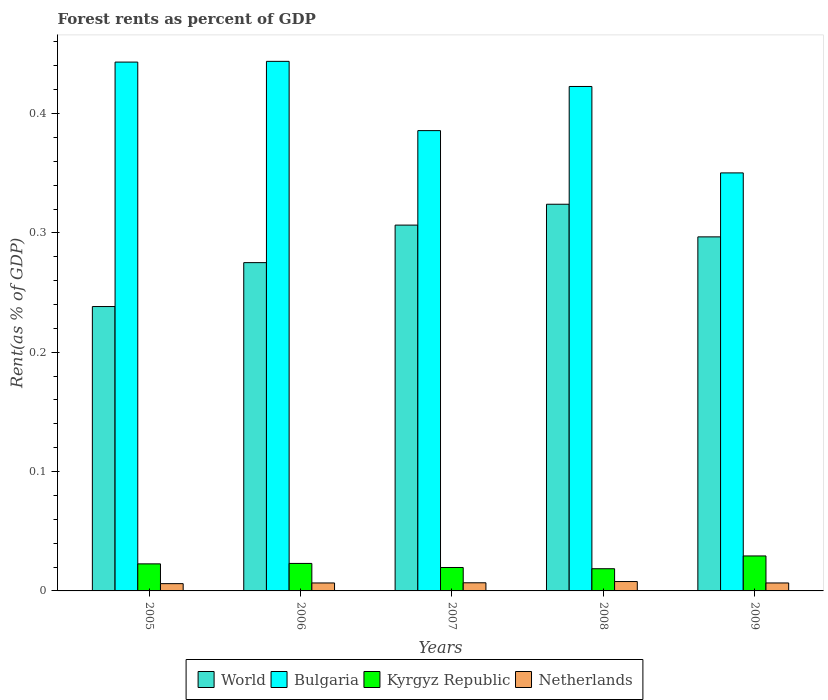How many different coloured bars are there?
Ensure brevity in your answer.  4. Are the number of bars on each tick of the X-axis equal?
Ensure brevity in your answer.  Yes. In how many cases, is the number of bars for a given year not equal to the number of legend labels?
Offer a terse response. 0. What is the forest rent in World in 2005?
Offer a terse response. 0.24. Across all years, what is the maximum forest rent in Kyrgyz Republic?
Keep it short and to the point. 0.03. Across all years, what is the minimum forest rent in Kyrgyz Republic?
Give a very brief answer. 0.02. In which year was the forest rent in Bulgaria maximum?
Keep it short and to the point. 2006. What is the total forest rent in Netherlands in the graph?
Your answer should be very brief. 0.03. What is the difference between the forest rent in Bulgaria in 2007 and that in 2008?
Keep it short and to the point. -0.04. What is the difference between the forest rent in Kyrgyz Republic in 2007 and the forest rent in Netherlands in 2008?
Keep it short and to the point. 0.01. What is the average forest rent in Bulgaria per year?
Offer a terse response. 0.41. In the year 2006, what is the difference between the forest rent in Kyrgyz Republic and forest rent in Netherlands?
Your answer should be very brief. 0.02. What is the ratio of the forest rent in Netherlands in 2006 to that in 2007?
Offer a very short reply. 0.98. Is the difference between the forest rent in Kyrgyz Republic in 2006 and 2008 greater than the difference between the forest rent in Netherlands in 2006 and 2008?
Your answer should be very brief. Yes. What is the difference between the highest and the second highest forest rent in Bulgaria?
Your answer should be very brief. 0. What is the difference between the highest and the lowest forest rent in Bulgaria?
Provide a succinct answer. 0.09. In how many years, is the forest rent in Kyrgyz Republic greater than the average forest rent in Kyrgyz Republic taken over all years?
Provide a short and direct response. 3. Is the sum of the forest rent in Netherlands in 2007 and 2008 greater than the maximum forest rent in Bulgaria across all years?
Your answer should be very brief. No. What does the 1st bar from the left in 2009 represents?
Offer a very short reply. World. What does the 2nd bar from the right in 2009 represents?
Your answer should be compact. Kyrgyz Republic. How many bars are there?
Provide a succinct answer. 20. Are all the bars in the graph horizontal?
Your answer should be very brief. No. How many years are there in the graph?
Make the answer very short. 5. What is the difference between two consecutive major ticks on the Y-axis?
Your answer should be compact. 0.1. Are the values on the major ticks of Y-axis written in scientific E-notation?
Your answer should be compact. No. Does the graph contain any zero values?
Your answer should be very brief. No. Where does the legend appear in the graph?
Provide a short and direct response. Bottom center. How many legend labels are there?
Your answer should be very brief. 4. How are the legend labels stacked?
Keep it short and to the point. Horizontal. What is the title of the graph?
Your answer should be very brief. Forest rents as percent of GDP. Does "Haiti" appear as one of the legend labels in the graph?
Provide a succinct answer. No. What is the label or title of the X-axis?
Offer a very short reply. Years. What is the label or title of the Y-axis?
Provide a short and direct response. Rent(as % of GDP). What is the Rent(as % of GDP) in World in 2005?
Make the answer very short. 0.24. What is the Rent(as % of GDP) in Bulgaria in 2005?
Your response must be concise. 0.44. What is the Rent(as % of GDP) of Kyrgyz Republic in 2005?
Your answer should be compact. 0.02. What is the Rent(as % of GDP) of Netherlands in 2005?
Ensure brevity in your answer.  0.01. What is the Rent(as % of GDP) of World in 2006?
Your answer should be very brief. 0.28. What is the Rent(as % of GDP) in Bulgaria in 2006?
Make the answer very short. 0.44. What is the Rent(as % of GDP) of Kyrgyz Republic in 2006?
Your answer should be very brief. 0.02. What is the Rent(as % of GDP) in Netherlands in 2006?
Provide a short and direct response. 0.01. What is the Rent(as % of GDP) of World in 2007?
Provide a short and direct response. 0.31. What is the Rent(as % of GDP) in Bulgaria in 2007?
Give a very brief answer. 0.39. What is the Rent(as % of GDP) in Kyrgyz Republic in 2007?
Your answer should be very brief. 0.02. What is the Rent(as % of GDP) in Netherlands in 2007?
Offer a terse response. 0.01. What is the Rent(as % of GDP) of World in 2008?
Provide a short and direct response. 0.32. What is the Rent(as % of GDP) in Bulgaria in 2008?
Your response must be concise. 0.42. What is the Rent(as % of GDP) in Kyrgyz Republic in 2008?
Offer a very short reply. 0.02. What is the Rent(as % of GDP) of Netherlands in 2008?
Keep it short and to the point. 0.01. What is the Rent(as % of GDP) in World in 2009?
Provide a short and direct response. 0.3. What is the Rent(as % of GDP) in Bulgaria in 2009?
Provide a succinct answer. 0.35. What is the Rent(as % of GDP) of Kyrgyz Republic in 2009?
Give a very brief answer. 0.03. What is the Rent(as % of GDP) in Netherlands in 2009?
Offer a very short reply. 0.01. Across all years, what is the maximum Rent(as % of GDP) in World?
Provide a short and direct response. 0.32. Across all years, what is the maximum Rent(as % of GDP) in Bulgaria?
Your response must be concise. 0.44. Across all years, what is the maximum Rent(as % of GDP) of Kyrgyz Republic?
Provide a succinct answer. 0.03. Across all years, what is the maximum Rent(as % of GDP) in Netherlands?
Make the answer very short. 0.01. Across all years, what is the minimum Rent(as % of GDP) in World?
Your answer should be compact. 0.24. Across all years, what is the minimum Rent(as % of GDP) in Bulgaria?
Your response must be concise. 0.35. Across all years, what is the minimum Rent(as % of GDP) in Kyrgyz Republic?
Make the answer very short. 0.02. Across all years, what is the minimum Rent(as % of GDP) of Netherlands?
Your answer should be very brief. 0.01. What is the total Rent(as % of GDP) in World in the graph?
Provide a short and direct response. 1.44. What is the total Rent(as % of GDP) of Bulgaria in the graph?
Offer a terse response. 2.05. What is the total Rent(as % of GDP) in Kyrgyz Republic in the graph?
Keep it short and to the point. 0.11. What is the total Rent(as % of GDP) of Netherlands in the graph?
Your response must be concise. 0.03. What is the difference between the Rent(as % of GDP) in World in 2005 and that in 2006?
Provide a succinct answer. -0.04. What is the difference between the Rent(as % of GDP) of Bulgaria in 2005 and that in 2006?
Ensure brevity in your answer.  -0. What is the difference between the Rent(as % of GDP) of Kyrgyz Republic in 2005 and that in 2006?
Ensure brevity in your answer.  -0. What is the difference between the Rent(as % of GDP) of Netherlands in 2005 and that in 2006?
Keep it short and to the point. -0. What is the difference between the Rent(as % of GDP) in World in 2005 and that in 2007?
Your answer should be compact. -0.07. What is the difference between the Rent(as % of GDP) of Bulgaria in 2005 and that in 2007?
Offer a terse response. 0.06. What is the difference between the Rent(as % of GDP) in Kyrgyz Republic in 2005 and that in 2007?
Make the answer very short. 0. What is the difference between the Rent(as % of GDP) of Netherlands in 2005 and that in 2007?
Your response must be concise. -0. What is the difference between the Rent(as % of GDP) of World in 2005 and that in 2008?
Offer a terse response. -0.09. What is the difference between the Rent(as % of GDP) of Bulgaria in 2005 and that in 2008?
Make the answer very short. 0.02. What is the difference between the Rent(as % of GDP) of Kyrgyz Republic in 2005 and that in 2008?
Ensure brevity in your answer.  0. What is the difference between the Rent(as % of GDP) in Netherlands in 2005 and that in 2008?
Your response must be concise. -0. What is the difference between the Rent(as % of GDP) in World in 2005 and that in 2009?
Provide a succinct answer. -0.06. What is the difference between the Rent(as % of GDP) of Bulgaria in 2005 and that in 2009?
Provide a short and direct response. 0.09. What is the difference between the Rent(as % of GDP) of Kyrgyz Republic in 2005 and that in 2009?
Provide a short and direct response. -0.01. What is the difference between the Rent(as % of GDP) of Netherlands in 2005 and that in 2009?
Make the answer very short. -0. What is the difference between the Rent(as % of GDP) of World in 2006 and that in 2007?
Your answer should be very brief. -0.03. What is the difference between the Rent(as % of GDP) of Bulgaria in 2006 and that in 2007?
Offer a terse response. 0.06. What is the difference between the Rent(as % of GDP) of Kyrgyz Republic in 2006 and that in 2007?
Provide a succinct answer. 0. What is the difference between the Rent(as % of GDP) of Netherlands in 2006 and that in 2007?
Your response must be concise. -0. What is the difference between the Rent(as % of GDP) in World in 2006 and that in 2008?
Your answer should be compact. -0.05. What is the difference between the Rent(as % of GDP) in Bulgaria in 2006 and that in 2008?
Your answer should be very brief. 0.02. What is the difference between the Rent(as % of GDP) in Kyrgyz Republic in 2006 and that in 2008?
Keep it short and to the point. 0. What is the difference between the Rent(as % of GDP) in Netherlands in 2006 and that in 2008?
Ensure brevity in your answer.  -0. What is the difference between the Rent(as % of GDP) in World in 2006 and that in 2009?
Provide a succinct answer. -0.02. What is the difference between the Rent(as % of GDP) in Bulgaria in 2006 and that in 2009?
Give a very brief answer. 0.09. What is the difference between the Rent(as % of GDP) of Kyrgyz Republic in 2006 and that in 2009?
Offer a very short reply. -0.01. What is the difference between the Rent(as % of GDP) of World in 2007 and that in 2008?
Make the answer very short. -0.02. What is the difference between the Rent(as % of GDP) of Bulgaria in 2007 and that in 2008?
Provide a short and direct response. -0.04. What is the difference between the Rent(as % of GDP) of Kyrgyz Republic in 2007 and that in 2008?
Your answer should be compact. 0. What is the difference between the Rent(as % of GDP) in Netherlands in 2007 and that in 2008?
Give a very brief answer. -0. What is the difference between the Rent(as % of GDP) of World in 2007 and that in 2009?
Give a very brief answer. 0.01. What is the difference between the Rent(as % of GDP) of Bulgaria in 2007 and that in 2009?
Offer a very short reply. 0.04. What is the difference between the Rent(as % of GDP) of Kyrgyz Republic in 2007 and that in 2009?
Ensure brevity in your answer.  -0.01. What is the difference between the Rent(as % of GDP) in World in 2008 and that in 2009?
Keep it short and to the point. 0.03. What is the difference between the Rent(as % of GDP) of Bulgaria in 2008 and that in 2009?
Provide a short and direct response. 0.07. What is the difference between the Rent(as % of GDP) of Kyrgyz Republic in 2008 and that in 2009?
Your answer should be very brief. -0.01. What is the difference between the Rent(as % of GDP) in Netherlands in 2008 and that in 2009?
Keep it short and to the point. 0. What is the difference between the Rent(as % of GDP) of World in 2005 and the Rent(as % of GDP) of Bulgaria in 2006?
Ensure brevity in your answer.  -0.21. What is the difference between the Rent(as % of GDP) in World in 2005 and the Rent(as % of GDP) in Kyrgyz Republic in 2006?
Your answer should be compact. 0.22. What is the difference between the Rent(as % of GDP) of World in 2005 and the Rent(as % of GDP) of Netherlands in 2006?
Give a very brief answer. 0.23. What is the difference between the Rent(as % of GDP) of Bulgaria in 2005 and the Rent(as % of GDP) of Kyrgyz Republic in 2006?
Provide a succinct answer. 0.42. What is the difference between the Rent(as % of GDP) in Bulgaria in 2005 and the Rent(as % of GDP) in Netherlands in 2006?
Make the answer very short. 0.44. What is the difference between the Rent(as % of GDP) in Kyrgyz Republic in 2005 and the Rent(as % of GDP) in Netherlands in 2006?
Your answer should be compact. 0.02. What is the difference between the Rent(as % of GDP) of World in 2005 and the Rent(as % of GDP) of Bulgaria in 2007?
Ensure brevity in your answer.  -0.15. What is the difference between the Rent(as % of GDP) of World in 2005 and the Rent(as % of GDP) of Kyrgyz Republic in 2007?
Your response must be concise. 0.22. What is the difference between the Rent(as % of GDP) in World in 2005 and the Rent(as % of GDP) in Netherlands in 2007?
Your answer should be very brief. 0.23. What is the difference between the Rent(as % of GDP) in Bulgaria in 2005 and the Rent(as % of GDP) in Kyrgyz Republic in 2007?
Offer a very short reply. 0.42. What is the difference between the Rent(as % of GDP) of Bulgaria in 2005 and the Rent(as % of GDP) of Netherlands in 2007?
Make the answer very short. 0.44. What is the difference between the Rent(as % of GDP) of Kyrgyz Republic in 2005 and the Rent(as % of GDP) of Netherlands in 2007?
Your answer should be compact. 0.02. What is the difference between the Rent(as % of GDP) of World in 2005 and the Rent(as % of GDP) of Bulgaria in 2008?
Provide a succinct answer. -0.18. What is the difference between the Rent(as % of GDP) in World in 2005 and the Rent(as % of GDP) in Kyrgyz Republic in 2008?
Your response must be concise. 0.22. What is the difference between the Rent(as % of GDP) in World in 2005 and the Rent(as % of GDP) in Netherlands in 2008?
Offer a very short reply. 0.23. What is the difference between the Rent(as % of GDP) in Bulgaria in 2005 and the Rent(as % of GDP) in Kyrgyz Republic in 2008?
Provide a succinct answer. 0.42. What is the difference between the Rent(as % of GDP) in Bulgaria in 2005 and the Rent(as % of GDP) in Netherlands in 2008?
Offer a very short reply. 0.44. What is the difference between the Rent(as % of GDP) in Kyrgyz Republic in 2005 and the Rent(as % of GDP) in Netherlands in 2008?
Your answer should be compact. 0.01. What is the difference between the Rent(as % of GDP) of World in 2005 and the Rent(as % of GDP) of Bulgaria in 2009?
Your answer should be compact. -0.11. What is the difference between the Rent(as % of GDP) in World in 2005 and the Rent(as % of GDP) in Kyrgyz Republic in 2009?
Your response must be concise. 0.21. What is the difference between the Rent(as % of GDP) of World in 2005 and the Rent(as % of GDP) of Netherlands in 2009?
Ensure brevity in your answer.  0.23. What is the difference between the Rent(as % of GDP) of Bulgaria in 2005 and the Rent(as % of GDP) of Kyrgyz Republic in 2009?
Ensure brevity in your answer.  0.41. What is the difference between the Rent(as % of GDP) in Bulgaria in 2005 and the Rent(as % of GDP) in Netherlands in 2009?
Ensure brevity in your answer.  0.44. What is the difference between the Rent(as % of GDP) in Kyrgyz Republic in 2005 and the Rent(as % of GDP) in Netherlands in 2009?
Ensure brevity in your answer.  0.02. What is the difference between the Rent(as % of GDP) of World in 2006 and the Rent(as % of GDP) of Bulgaria in 2007?
Give a very brief answer. -0.11. What is the difference between the Rent(as % of GDP) in World in 2006 and the Rent(as % of GDP) in Kyrgyz Republic in 2007?
Your answer should be compact. 0.26. What is the difference between the Rent(as % of GDP) of World in 2006 and the Rent(as % of GDP) of Netherlands in 2007?
Provide a succinct answer. 0.27. What is the difference between the Rent(as % of GDP) of Bulgaria in 2006 and the Rent(as % of GDP) of Kyrgyz Republic in 2007?
Offer a terse response. 0.42. What is the difference between the Rent(as % of GDP) of Bulgaria in 2006 and the Rent(as % of GDP) of Netherlands in 2007?
Your answer should be very brief. 0.44. What is the difference between the Rent(as % of GDP) in Kyrgyz Republic in 2006 and the Rent(as % of GDP) in Netherlands in 2007?
Provide a succinct answer. 0.02. What is the difference between the Rent(as % of GDP) of World in 2006 and the Rent(as % of GDP) of Bulgaria in 2008?
Give a very brief answer. -0.15. What is the difference between the Rent(as % of GDP) of World in 2006 and the Rent(as % of GDP) of Kyrgyz Republic in 2008?
Offer a very short reply. 0.26. What is the difference between the Rent(as % of GDP) of World in 2006 and the Rent(as % of GDP) of Netherlands in 2008?
Offer a very short reply. 0.27. What is the difference between the Rent(as % of GDP) in Bulgaria in 2006 and the Rent(as % of GDP) in Kyrgyz Republic in 2008?
Provide a short and direct response. 0.43. What is the difference between the Rent(as % of GDP) in Bulgaria in 2006 and the Rent(as % of GDP) in Netherlands in 2008?
Offer a terse response. 0.44. What is the difference between the Rent(as % of GDP) of Kyrgyz Republic in 2006 and the Rent(as % of GDP) of Netherlands in 2008?
Offer a terse response. 0.02. What is the difference between the Rent(as % of GDP) of World in 2006 and the Rent(as % of GDP) of Bulgaria in 2009?
Offer a very short reply. -0.08. What is the difference between the Rent(as % of GDP) in World in 2006 and the Rent(as % of GDP) in Kyrgyz Republic in 2009?
Offer a terse response. 0.25. What is the difference between the Rent(as % of GDP) of World in 2006 and the Rent(as % of GDP) of Netherlands in 2009?
Your answer should be compact. 0.27. What is the difference between the Rent(as % of GDP) in Bulgaria in 2006 and the Rent(as % of GDP) in Kyrgyz Republic in 2009?
Make the answer very short. 0.41. What is the difference between the Rent(as % of GDP) in Bulgaria in 2006 and the Rent(as % of GDP) in Netherlands in 2009?
Give a very brief answer. 0.44. What is the difference between the Rent(as % of GDP) in Kyrgyz Republic in 2006 and the Rent(as % of GDP) in Netherlands in 2009?
Your answer should be very brief. 0.02. What is the difference between the Rent(as % of GDP) of World in 2007 and the Rent(as % of GDP) of Bulgaria in 2008?
Provide a succinct answer. -0.12. What is the difference between the Rent(as % of GDP) of World in 2007 and the Rent(as % of GDP) of Kyrgyz Republic in 2008?
Make the answer very short. 0.29. What is the difference between the Rent(as % of GDP) of World in 2007 and the Rent(as % of GDP) of Netherlands in 2008?
Offer a very short reply. 0.3. What is the difference between the Rent(as % of GDP) of Bulgaria in 2007 and the Rent(as % of GDP) of Kyrgyz Republic in 2008?
Provide a short and direct response. 0.37. What is the difference between the Rent(as % of GDP) in Bulgaria in 2007 and the Rent(as % of GDP) in Netherlands in 2008?
Your response must be concise. 0.38. What is the difference between the Rent(as % of GDP) in Kyrgyz Republic in 2007 and the Rent(as % of GDP) in Netherlands in 2008?
Make the answer very short. 0.01. What is the difference between the Rent(as % of GDP) of World in 2007 and the Rent(as % of GDP) of Bulgaria in 2009?
Your answer should be compact. -0.04. What is the difference between the Rent(as % of GDP) of World in 2007 and the Rent(as % of GDP) of Kyrgyz Republic in 2009?
Provide a short and direct response. 0.28. What is the difference between the Rent(as % of GDP) in World in 2007 and the Rent(as % of GDP) in Netherlands in 2009?
Your answer should be very brief. 0.3. What is the difference between the Rent(as % of GDP) of Bulgaria in 2007 and the Rent(as % of GDP) of Kyrgyz Republic in 2009?
Your answer should be very brief. 0.36. What is the difference between the Rent(as % of GDP) of Bulgaria in 2007 and the Rent(as % of GDP) of Netherlands in 2009?
Make the answer very short. 0.38. What is the difference between the Rent(as % of GDP) of Kyrgyz Republic in 2007 and the Rent(as % of GDP) of Netherlands in 2009?
Provide a succinct answer. 0.01. What is the difference between the Rent(as % of GDP) in World in 2008 and the Rent(as % of GDP) in Bulgaria in 2009?
Your answer should be compact. -0.03. What is the difference between the Rent(as % of GDP) of World in 2008 and the Rent(as % of GDP) of Kyrgyz Republic in 2009?
Provide a short and direct response. 0.29. What is the difference between the Rent(as % of GDP) of World in 2008 and the Rent(as % of GDP) of Netherlands in 2009?
Your answer should be very brief. 0.32. What is the difference between the Rent(as % of GDP) in Bulgaria in 2008 and the Rent(as % of GDP) in Kyrgyz Republic in 2009?
Your answer should be very brief. 0.39. What is the difference between the Rent(as % of GDP) of Bulgaria in 2008 and the Rent(as % of GDP) of Netherlands in 2009?
Provide a short and direct response. 0.42. What is the difference between the Rent(as % of GDP) in Kyrgyz Republic in 2008 and the Rent(as % of GDP) in Netherlands in 2009?
Your response must be concise. 0.01. What is the average Rent(as % of GDP) in World per year?
Your answer should be compact. 0.29. What is the average Rent(as % of GDP) in Bulgaria per year?
Your response must be concise. 0.41. What is the average Rent(as % of GDP) in Kyrgyz Republic per year?
Make the answer very short. 0.02. What is the average Rent(as % of GDP) of Netherlands per year?
Provide a succinct answer. 0.01. In the year 2005, what is the difference between the Rent(as % of GDP) of World and Rent(as % of GDP) of Bulgaria?
Provide a succinct answer. -0.2. In the year 2005, what is the difference between the Rent(as % of GDP) in World and Rent(as % of GDP) in Kyrgyz Republic?
Offer a very short reply. 0.22. In the year 2005, what is the difference between the Rent(as % of GDP) of World and Rent(as % of GDP) of Netherlands?
Your answer should be compact. 0.23. In the year 2005, what is the difference between the Rent(as % of GDP) in Bulgaria and Rent(as % of GDP) in Kyrgyz Republic?
Your answer should be compact. 0.42. In the year 2005, what is the difference between the Rent(as % of GDP) of Bulgaria and Rent(as % of GDP) of Netherlands?
Give a very brief answer. 0.44. In the year 2005, what is the difference between the Rent(as % of GDP) in Kyrgyz Republic and Rent(as % of GDP) in Netherlands?
Make the answer very short. 0.02. In the year 2006, what is the difference between the Rent(as % of GDP) of World and Rent(as % of GDP) of Bulgaria?
Keep it short and to the point. -0.17. In the year 2006, what is the difference between the Rent(as % of GDP) of World and Rent(as % of GDP) of Kyrgyz Republic?
Provide a succinct answer. 0.25. In the year 2006, what is the difference between the Rent(as % of GDP) of World and Rent(as % of GDP) of Netherlands?
Provide a short and direct response. 0.27. In the year 2006, what is the difference between the Rent(as % of GDP) in Bulgaria and Rent(as % of GDP) in Kyrgyz Republic?
Make the answer very short. 0.42. In the year 2006, what is the difference between the Rent(as % of GDP) of Bulgaria and Rent(as % of GDP) of Netherlands?
Your answer should be compact. 0.44. In the year 2006, what is the difference between the Rent(as % of GDP) of Kyrgyz Republic and Rent(as % of GDP) of Netherlands?
Ensure brevity in your answer.  0.02. In the year 2007, what is the difference between the Rent(as % of GDP) of World and Rent(as % of GDP) of Bulgaria?
Provide a succinct answer. -0.08. In the year 2007, what is the difference between the Rent(as % of GDP) in World and Rent(as % of GDP) in Kyrgyz Republic?
Make the answer very short. 0.29. In the year 2007, what is the difference between the Rent(as % of GDP) in World and Rent(as % of GDP) in Netherlands?
Provide a short and direct response. 0.3. In the year 2007, what is the difference between the Rent(as % of GDP) in Bulgaria and Rent(as % of GDP) in Kyrgyz Republic?
Offer a very short reply. 0.37. In the year 2007, what is the difference between the Rent(as % of GDP) of Bulgaria and Rent(as % of GDP) of Netherlands?
Provide a short and direct response. 0.38. In the year 2007, what is the difference between the Rent(as % of GDP) in Kyrgyz Republic and Rent(as % of GDP) in Netherlands?
Offer a terse response. 0.01. In the year 2008, what is the difference between the Rent(as % of GDP) in World and Rent(as % of GDP) in Bulgaria?
Offer a terse response. -0.1. In the year 2008, what is the difference between the Rent(as % of GDP) in World and Rent(as % of GDP) in Kyrgyz Republic?
Provide a succinct answer. 0.31. In the year 2008, what is the difference between the Rent(as % of GDP) of World and Rent(as % of GDP) of Netherlands?
Ensure brevity in your answer.  0.32. In the year 2008, what is the difference between the Rent(as % of GDP) in Bulgaria and Rent(as % of GDP) in Kyrgyz Republic?
Give a very brief answer. 0.4. In the year 2008, what is the difference between the Rent(as % of GDP) in Bulgaria and Rent(as % of GDP) in Netherlands?
Your response must be concise. 0.41. In the year 2008, what is the difference between the Rent(as % of GDP) in Kyrgyz Republic and Rent(as % of GDP) in Netherlands?
Ensure brevity in your answer.  0.01. In the year 2009, what is the difference between the Rent(as % of GDP) of World and Rent(as % of GDP) of Bulgaria?
Offer a terse response. -0.05. In the year 2009, what is the difference between the Rent(as % of GDP) of World and Rent(as % of GDP) of Kyrgyz Republic?
Your answer should be very brief. 0.27. In the year 2009, what is the difference between the Rent(as % of GDP) of World and Rent(as % of GDP) of Netherlands?
Offer a very short reply. 0.29. In the year 2009, what is the difference between the Rent(as % of GDP) of Bulgaria and Rent(as % of GDP) of Kyrgyz Republic?
Ensure brevity in your answer.  0.32. In the year 2009, what is the difference between the Rent(as % of GDP) in Bulgaria and Rent(as % of GDP) in Netherlands?
Your response must be concise. 0.34. In the year 2009, what is the difference between the Rent(as % of GDP) in Kyrgyz Republic and Rent(as % of GDP) in Netherlands?
Offer a terse response. 0.02. What is the ratio of the Rent(as % of GDP) in World in 2005 to that in 2006?
Provide a succinct answer. 0.87. What is the ratio of the Rent(as % of GDP) of Kyrgyz Republic in 2005 to that in 2006?
Give a very brief answer. 0.98. What is the ratio of the Rent(as % of GDP) of Netherlands in 2005 to that in 2006?
Ensure brevity in your answer.  0.91. What is the ratio of the Rent(as % of GDP) of World in 2005 to that in 2007?
Offer a terse response. 0.78. What is the ratio of the Rent(as % of GDP) in Bulgaria in 2005 to that in 2007?
Offer a very short reply. 1.15. What is the ratio of the Rent(as % of GDP) in Kyrgyz Republic in 2005 to that in 2007?
Offer a very short reply. 1.15. What is the ratio of the Rent(as % of GDP) in Netherlands in 2005 to that in 2007?
Provide a short and direct response. 0.89. What is the ratio of the Rent(as % of GDP) in World in 2005 to that in 2008?
Provide a succinct answer. 0.74. What is the ratio of the Rent(as % of GDP) of Bulgaria in 2005 to that in 2008?
Offer a terse response. 1.05. What is the ratio of the Rent(as % of GDP) in Kyrgyz Republic in 2005 to that in 2008?
Keep it short and to the point. 1.22. What is the ratio of the Rent(as % of GDP) in Netherlands in 2005 to that in 2008?
Offer a very short reply. 0.77. What is the ratio of the Rent(as % of GDP) of World in 2005 to that in 2009?
Provide a succinct answer. 0.8. What is the ratio of the Rent(as % of GDP) in Bulgaria in 2005 to that in 2009?
Make the answer very short. 1.27. What is the ratio of the Rent(as % of GDP) of Kyrgyz Republic in 2005 to that in 2009?
Provide a short and direct response. 0.77. What is the ratio of the Rent(as % of GDP) of Netherlands in 2005 to that in 2009?
Your response must be concise. 0.91. What is the ratio of the Rent(as % of GDP) of World in 2006 to that in 2007?
Keep it short and to the point. 0.9. What is the ratio of the Rent(as % of GDP) in Bulgaria in 2006 to that in 2007?
Provide a succinct answer. 1.15. What is the ratio of the Rent(as % of GDP) in Kyrgyz Republic in 2006 to that in 2007?
Your response must be concise. 1.17. What is the ratio of the Rent(as % of GDP) in Netherlands in 2006 to that in 2007?
Provide a succinct answer. 0.98. What is the ratio of the Rent(as % of GDP) of World in 2006 to that in 2008?
Ensure brevity in your answer.  0.85. What is the ratio of the Rent(as % of GDP) in Bulgaria in 2006 to that in 2008?
Offer a terse response. 1.05. What is the ratio of the Rent(as % of GDP) in Kyrgyz Republic in 2006 to that in 2008?
Offer a terse response. 1.24. What is the ratio of the Rent(as % of GDP) of Netherlands in 2006 to that in 2008?
Your answer should be compact. 0.85. What is the ratio of the Rent(as % of GDP) of World in 2006 to that in 2009?
Your answer should be very brief. 0.93. What is the ratio of the Rent(as % of GDP) in Bulgaria in 2006 to that in 2009?
Offer a terse response. 1.27. What is the ratio of the Rent(as % of GDP) in Kyrgyz Republic in 2006 to that in 2009?
Offer a very short reply. 0.79. What is the ratio of the Rent(as % of GDP) in World in 2007 to that in 2008?
Offer a very short reply. 0.95. What is the ratio of the Rent(as % of GDP) in Bulgaria in 2007 to that in 2008?
Provide a short and direct response. 0.91. What is the ratio of the Rent(as % of GDP) of Kyrgyz Republic in 2007 to that in 2008?
Provide a short and direct response. 1.06. What is the ratio of the Rent(as % of GDP) in Netherlands in 2007 to that in 2008?
Your answer should be very brief. 0.87. What is the ratio of the Rent(as % of GDP) in World in 2007 to that in 2009?
Offer a very short reply. 1.03. What is the ratio of the Rent(as % of GDP) of Bulgaria in 2007 to that in 2009?
Make the answer very short. 1.1. What is the ratio of the Rent(as % of GDP) in Kyrgyz Republic in 2007 to that in 2009?
Your answer should be compact. 0.67. What is the ratio of the Rent(as % of GDP) in Netherlands in 2007 to that in 2009?
Keep it short and to the point. 1.02. What is the ratio of the Rent(as % of GDP) in World in 2008 to that in 2009?
Your answer should be compact. 1.09. What is the ratio of the Rent(as % of GDP) of Bulgaria in 2008 to that in 2009?
Offer a very short reply. 1.21. What is the ratio of the Rent(as % of GDP) of Kyrgyz Republic in 2008 to that in 2009?
Make the answer very short. 0.63. What is the ratio of the Rent(as % of GDP) of Netherlands in 2008 to that in 2009?
Keep it short and to the point. 1.18. What is the difference between the highest and the second highest Rent(as % of GDP) of World?
Keep it short and to the point. 0.02. What is the difference between the highest and the second highest Rent(as % of GDP) in Bulgaria?
Your answer should be very brief. 0. What is the difference between the highest and the second highest Rent(as % of GDP) in Kyrgyz Republic?
Offer a very short reply. 0.01. What is the difference between the highest and the second highest Rent(as % of GDP) of Netherlands?
Provide a short and direct response. 0. What is the difference between the highest and the lowest Rent(as % of GDP) in World?
Keep it short and to the point. 0.09. What is the difference between the highest and the lowest Rent(as % of GDP) of Bulgaria?
Ensure brevity in your answer.  0.09. What is the difference between the highest and the lowest Rent(as % of GDP) in Kyrgyz Republic?
Your answer should be compact. 0.01. What is the difference between the highest and the lowest Rent(as % of GDP) in Netherlands?
Provide a short and direct response. 0. 